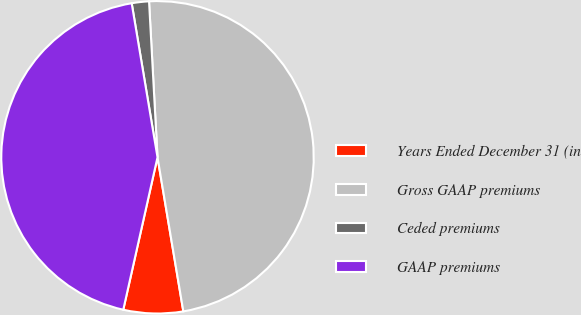Convert chart to OTSL. <chart><loc_0><loc_0><loc_500><loc_500><pie_chart><fcel>Years Ended December 31 (in<fcel>Gross GAAP premiums<fcel>Ceded premiums<fcel>GAAP premiums<nl><fcel>6.16%<fcel>48.22%<fcel>1.78%<fcel>43.84%<nl></chart> 